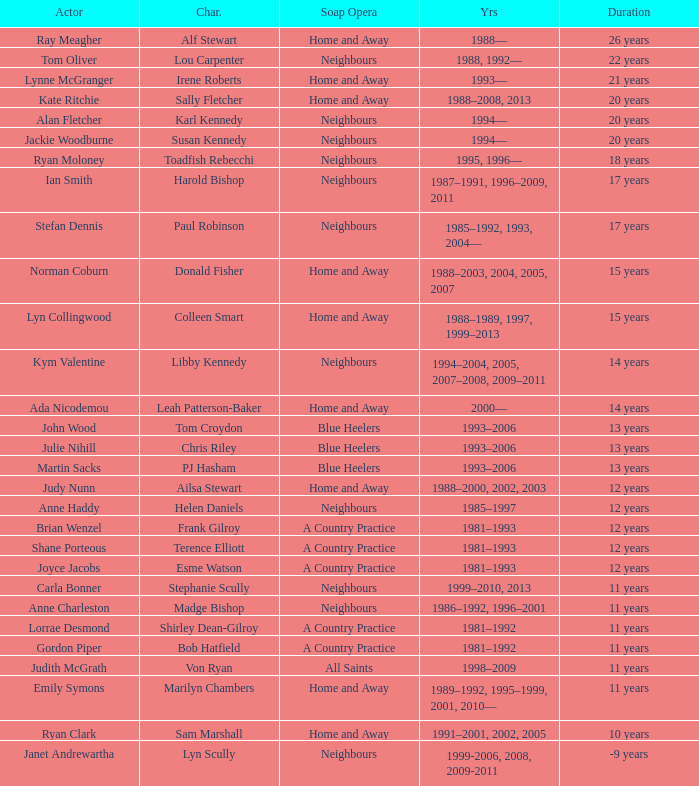Which actor played Harold Bishop for 17 years? Ian Smith. 